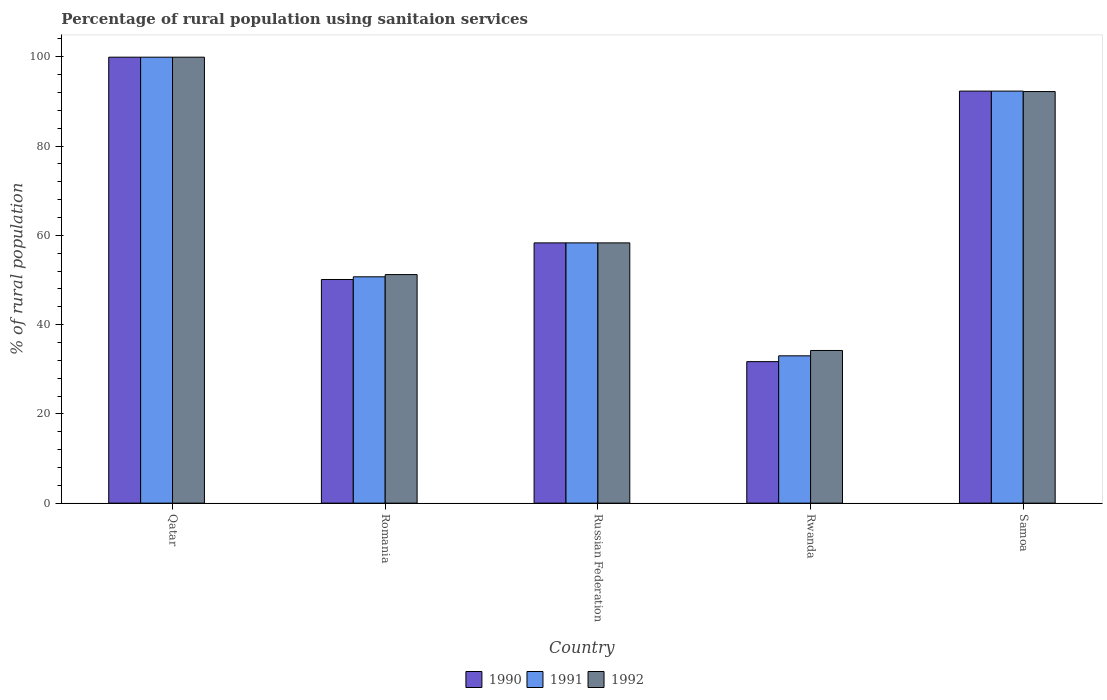How many different coloured bars are there?
Your response must be concise. 3. How many groups of bars are there?
Your answer should be compact. 5. Are the number of bars per tick equal to the number of legend labels?
Make the answer very short. Yes. Are the number of bars on each tick of the X-axis equal?
Offer a very short reply. Yes. How many bars are there on the 1st tick from the left?
Your answer should be very brief. 3. How many bars are there on the 2nd tick from the right?
Keep it short and to the point. 3. What is the label of the 4th group of bars from the left?
Your answer should be compact. Rwanda. In how many cases, is the number of bars for a given country not equal to the number of legend labels?
Your answer should be compact. 0. What is the percentage of rural population using sanitaion services in 1991 in Qatar?
Keep it short and to the point. 99.9. Across all countries, what is the maximum percentage of rural population using sanitaion services in 1990?
Make the answer very short. 99.9. Across all countries, what is the minimum percentage of rural population using sanitaion services in 1990?
Ensure brevity in your answer.  31.7. In which country was the percentage of rural population using sanitaion services in 1992 maximum?
Make the answer very short. Qatar. In which country was the percentage of rural population using sanitaion services in 1990 minimum?
Your answer should be very brief. Rwanda. What is the total percentage of rural population using sanitaion services in 1991 in the graph?
Ensure brevity in your answer.  334.2. What is the difference between the percentage of rural population using sanitaion services in 1990 in Romania and that in Rwanda?
Keep it short and to the point. 18.4. What is the difference between the percentage of rural population using sanitaion services in 1990 in Qatar and the percentage of rural population using sanitaion services in 1992 in Russian Federation?
Your response must be concise. 41.6. What is the average percentage of rural population using sanitaion services in 1992 per country?
Offer a very short reply. 67.16. What is the difference between the percentage of rural population using sanitaion services of/in 1992 and percentage of rural population using sanitaion services of/in 1991 in Samoa?
Offer a terse response. -0.1. What is the ratio of the percentage of rural population using sanitaion services in 1991 in Rwanda to that in Samoa?
Your answer should be very brief. 0.36. Is the percentage of rural population using sanitaion services in 1990 in Qatar less than that in Samoa?
Make the answer very short. No. Is the difference between the percentage of rural population using sanitaion services in 1992 in Russian Federation and Samoa greater than the difference between the percentage of rural population using sanitaion services in 1991 in Russian Federation and Samoa?
Give a very brief answer. Yes. What is the difference between the highest and the second highest percentage of rural population using sanitaion services in 1990?
Provide a succinct answer. -41.6. What is the difference between the highest and the lowest percentage of rural population using sanitaion services in 1992?
Your response must be concise. 65.7. Is the sum of the percentage of rural population using sanitaion services in 1991 in Qatar and Romania greater than the maximum percentage of rural population using sanitaion services in 1992 across all countries?
Provide a short and direct response. Yes. What is the difference between two consecutive major ticks on the Y-axis?
Provide a short and direct response. 20. How many legend labels are there?
Ensure brevity in your answer.  3. How are the legend labels stacked?
Offer a terse response. Horizontal. What is the title of the graph?
Ensure brevity in your answer.  Percentage of rural population using sanitaion services. Does "2010" appear as one of the legend labels in the graph?
Offer a terse response. No. What is the label or title of the Y-axis?
Your answer should be compact. % of rural population. What is the % of rural population of 1990 in Qatar?
Offer a very short reply. 99.9. What is the % of rural population in 1991 in Qatar?
Keep it short and to the point. 99.9. What is the % of rural population in 1992 in Qatar?
Offer a terse response. 99.9. What is the % of rural population of 1990 in Romania?
Offer a terse response. 50.1. What is the % of rural population of 1991 in Romania?
Offer a very short reply. 50.7. What is the % of rural population in 1992 in Romania?
Make the answer very short. 51.2. What is the % of rural population of 1990 in Russian Federation?
Give a very brief answer. 58.3. What is the % of rural population in 1991 in Russian Federation?
Provide a short and direct response. 58.3. What is the % of rural population in 1992 in Russian Federation?
Offer a very short reply. 58.3. What is the % of rural population of 1990 in Rwanda?
Your response must be concise. 31.7. What is the % of rural population of 1991 in Rwanda?
Make the answer very short. 33. What is the % of rural population of 1992 in Rwanda?
Offer a terse response. 34.2. What is the % of rural population of 1990 in Samoa?
Provide a short and direct response. 92.3. What is the % of rural population of 1991 in Samoa?
Your answer should be compact. 92.3. What is the % of rural population of 1992 in Samoa?
Your response must be concise. 92.2. Across all countries, what is the maximum % of rural population of 1990?
Your answer should be compact. 99.9. Across all countries, what is the maximum % of rural population of 1991?
Make the answer very short. 99.9. Across all countries, what is the maximum % of rural population of 1992?
Your response must be concise. 99.9. Across all countries, what is the minimum % of rural population in 1990?
Ensure brevity in your answer.  31.7. Across all countries, what is the minimum % of rural population of 1992?
Your answer should be compact. 34.2. What is the total % of rural population in 1990 in the graph?
Your answer should be very brief. 332.3. What is the total % of rural population of 1991 in the graph?
Provide a short and direct response. 334.2. What is the total % of rural population of 1992 in the graph?
Keep it short and to the point. 335.8. What is the difference between the % of rural population in 1990 in Qatar and that in Romania?
Give a very brief answer. 49.8. What is the difference between the % of rural population of 1991 in Qatar and that in Romania?
Offer a terse response. 49.2. What is the difference between the % of rural population of 1992 in Qatar and that in Romania?
Keep it short and to the point. 48.7. What is the difference between the % of rural population in 1990 in Qatar and that in Russian Federation?
Ensure brevity in your answer.  41.6. What is the difference between the % of rural population of 1991 in Qatar and that in Russian Federation?
Keep it short and to the point. 41.6. What is the difference between the % of rural population in 1992 in Qatar and that in Russian Federation?
Offer a terse response. 41.6. What is the difference between the % of rural population of 1990 in Qatar and that in Rwanda?
Provide a succinct answer. 68.2. What is the difference between the % of rural population of 1991 in Qatar and that in Rwanda?
Provide a short and direct response. 66.9. What is the difference between the % of rural population in 1992 in Qatar and that in Rwanda?
Ensure brevity in your answer.  65.7. What is the difference between the % of rural population in 1990 in Qatar and that in Samoa?
Provide a short and direct response. 7.6. What is the difference between the % of rural population of 1991 in Romania and that in Russian Federation?
Offer a very short reply. -7.6. What is the difference between the % of rural population of 1990 in Romania and that in Samoa?
Keep it short and to the point. -42.2. What is the difference between the % of rural population of 1991 in Romania and that in Samoa?
Keep it short and to the point. -41.6. What is the difference between the % of rural population of 1992 in Romania and that in Samoa?
Offer a terse response. -41. What is the difference between the % of rural population of 1990 in Russian Federation and that in Rwanda?
Give a very brief answer. 26.6. What is the difference between the % of rural population in 1991 in Russian Federation and that in Rwanda?
Offer a terse response. 25.3. What is the difference between the % of rural population in 1992 in Russian Federation and that in Rwanda?
Your response must be concise. 24.1. What is the difference between the % of rural population of 1990 in Russian Federation and that in Samoa?
Your response must be concise. -34. What is the difference between the % of rural population of 1991 in Russian Federation and that in Samoa?
Ensure brevity in your answer.  -34. What is the difference between the % of rural population of 1992 in Russian Federation and that in Samoa?
Offer a terse response. -33.9. What is the difference between the % of rural population in 1990 in Rwanda and that in Samoa?
Ensure brevity in your answer.  -60.6. What is the difference between the % of rural population of 1991 in Rwanda and that in Samoa?
Give a very brief answer. -59.3. What is the difference between the % of rural population of 1992 in Rwanda and that in Samoa?
Your answer should be very brief. -58. What is the difference between the % of rural population of 1990 in Qatar and the % of rural population of 1991 in Romania?
Offer a terse response. 49.2. What is the difference between the % of rural population of 1990 in Qatar and the % of rural population of 1992 in Romania?
Your answer should be compact. 48.7. What is the difference between the % of rural population of 1991 in Qatar and the % of rural population of 1992 in Romania?
Your response must be concise. 48.7. What is the difference between the % of rural population in 1990 in Qatar and the % of rural population in 1991 in Russian Federation?
Your answer should be very brief. 41.6. What is the difference between the % of rural population of 1990 in Qatar and the % of rural population of 1992 in Russian Federation?
Offer a terse response. 41.6. What is the difference between the % of rural population of 1991 in Qatar and the % of rural population of 1992 in Russian Federation?
Your response must be concise. 41.6. What is the difference between the % of rural population in 1990 in Qatar and the % of rural population in 1991 in Rwanda?
Provide a succinct answer. 66.9. What is the difference between the % of rural population of 1990 in Qatar and the % of rural population of 1992 in Rwanda?
Give a very brief answer. 65.7. What is the difference between the % of rural population of 1991 in Qatar and the % of rural population of 1992 in Rwanda?
Your answer should be very brief. 65.7. What is the difference between the % of rural population of 1990 in Qatar and the % of rural population of 1991 in Samoa?
Offer a very short reply. 7.6. What is the difference between the % of rural population in 1991 in Qatar and the % of rural population in 1992 in Samoa?
Offer a very short reply. 7.7. What is the difference between the % of rural population in 1990 in Romania and the % of rural population in 1991 in Russian Federation?
Offer a very short reply. -8.2. What is the difference between the % of rural population of 1991 in Romania and the % of rural population of 1992 in Russian Federation?
Provide a short and direct response. -7.6. What is the difference between the % of rural population of 1990 in Romania and the % of rural population of 1992 in Rwanda?
Keep it short and to the point. 15.9. What is the difference between the % of rural population in 1990 in Romania and the % of rural population in 1991 in Samoa?
Ensure brevity in your answer.  -42.2. What is the difference between the % of rural population in 1990 in Romania and the % of rural population in 1992 in Samoa?
Give a very brief answer. -42.1. What is the difference between the % of rural population of 1991 in Romania and the % of rural population of 1992 in Samoa?
Make the answer very short. -41.5. What is the difference between the % of rural population of 1990 in Russian Federation and the % of rural population of 1991 in Rwanda?
Provide a short and direct response. 25.3. What is the difference between the % of rural population of 1990 in Russian Federation and the % of rural population of 1992 in Rwanda?
Offer a terse response. 24.1. What is the difference between the % of rural population of 1991 in Russian Federation and the % of rural population of 1992 in Rwanda?
Ensure brevity in your answer.  24.1. What is the difference between the % of rural population in 1990 in Russian Federation and the % of rural population in 1991 in Samoa?
Keep it short and to the point. -34. What is the difference between the % of rural population of 1990 in Russian Federation and the % of rural population of 1992 in Samoa?
Make the answer very short. -33.9. What is the difference between the % of rural population in 1991 in Russian Federation and the % of rural population in 1992 in Samoa?
Your answer should be compact. -33.9. What is the difference between the % of rural population in 1990 in Rwanda and the % of rural population in 1991 in Samoa?
Your answer should be compact. -60.6. What is the difference between the % of rural population of 1990 in Rwanda and the % of rural population of 1992 in Samoa?
Make the answer very short. -60.5. What is the difference between the % of rural population in 1991 in Rwanda and the % of rural population in 1992 in Samoa?
Provide a short and direct response. -59.2. What is the average % of rural population in 1990 per country?
Your answer should be very brief. 66.46. What is the average % of rural population in 1991 per country?
Ensure brevity in your answer.  66.84. What is the average % of rural population of 1992 per country?
Your response must be concise. 67.16. What is the difference between the % of rural population in 1990 and % of rural population in 1991 in Qatar?
Provide a short and direct response. 0. What is the difference between the % of rural population in 1991 and % of rural population in 1992 in Romania?
Your answer should be compact. -0.5. What is the difference between the % of rural population of 1990 and % of rural population of 1991 in Russian Federation?
Your answer should be very brief. 0. What is the difference between the % of rural population of 1991 and % of rural population of 1992 in Russian Federation?
Make the answer very short. 0. What is the difference between the % of rural population in 1991 and % of rural population in 1992 in Rwanda?
Offer a terse response. -1.2. What is the ratio of the % of rural population in 1990 in Qatar to that in Romania?
Your response must be concise. 1.99. What is the ratio of the % of rural population in 1991 in Qatar to that in Romania?
Offer a terse response. 1.97. What is the ratio of the % of rural population of 1992 in Qatar to that in Romania?
Offer a very short reply. 1.95. What is the ratio of the % of rural population in 1990 in Qatar to that in Russian Federation?
Ensure brevity in your answer.  1.71. What is the ratio of the % of rural population in 1991 in Qatar to that in Russian Federation?
Offer a terse response. 1.71. What is the ratio of the % of rural population in 1992 in Qatar to that in Russian Federation?
Give a very brief answer. 1.71. What is the ratio of the % of rural population in 1990 in Qatar to that in Rwanda?
Your response must be concise. 3.15. What is the ratio of the % of rural population in 1991 in Qatar to that in Rwanda?
Your response must be concise. 3.03. What is the ratio of the % of rural population in 1992 in Qatar to that in Rwanda?
Ensure brevity in your answer.  2.92. What is the ratio of the % of rural population of 1990 in Qatar to that in Samoa?
Provide a succinct answer. 1.08. What is the ratio of the % of rural population in 1991 in Qatar to that in Samoa?
Provide a succinct answer. 1.08. What is the ratio of the % of rural population in 1992 in Qatar to that in Samoa?
Give a very brief answer. 1.08. What is the ratio of the % of rural population of 1990 in Romania to that in Russian Federation?
Your answer should be compact. 0.86. What is the ratio of the % of rural population in 1991 in Romania to that in Russian Federation?
Your answer should be compact. 0.87. What is the ratio of the % of rural population of 1992 in Romania to that in Russian Federation?
Your response must be concise. 0.88. What is the ratio of the % of rural population of 1990 in Romania to that in Rwanda?
Your answer should be compact. 1.58. What is the ratio of the % of rural population of 1991 in Romania to that in Rwanda?
Your answer should be very brief. 1.54. What is the ratio of the % of rural population of 1992 in Romania to that in Rwanda?
Provide a short and direct response. 1.5. What is the ratio of the % of rural population in 1990 in Romania to that in Samoa?
Provide a succinct answer. 0.54. What is the ratio of the % of rural population in 1991 in Romania to that in Samoa?
Your answer should be compact. 0.55. What is the ratio of the % of rural population of 1992 in Romania to that in Samoa?
Keep it short and to the point. 0.56. What is the ratio of the % of rural population in 1990 in Russian Federation to that in Rwanda?
Provide a short and direct response. 1.84. What is the ratio of the % of rural population in 1991 in Russian Federation to that in Rwanda?
Give a very brief answer. 1.77. What is the ratio of the % of rural population in 1992 in Russian Federation to that in Rwanda?
Offer a terse response. 1.7. What is the ratio of the % of rural population of 1990 in Russian Federation to that in Samoa?
Keep it short and to the point. 0.63. What is the ratio of the % of rural population in 1991 in Russian Federation to that in Samoa?
Give a very brief answer. 0.63. What is the ratio of the % of rural population of 1992 in Russian Federation to that in Samoa?
Offer a very short reply. 0.63. What is the ratio of the % of rural population in 1990 in Rwanda to that in Samoa?
Ensure brevity in your answer.  0.34. What is the ratio of the % of rural population of 1991 in Rwanda to that in Samoa?
Your answer should be compact. 0.36. What is the ratio of the % of rural population in 1992 in Rwanda to that in Samoa?
Give a very brief answer. 0.37. What is the difference between the highest and the lowest % of rural population of 1990?
Keep it short and to the point. 68.2. What is the difference between the highest and the lowest % of rural population of 1991?
Offer a terse response. 66.9. What is the difference between the highest and the lowest % of rural population of 1992?
Keep it short and to the point. 65.7. 